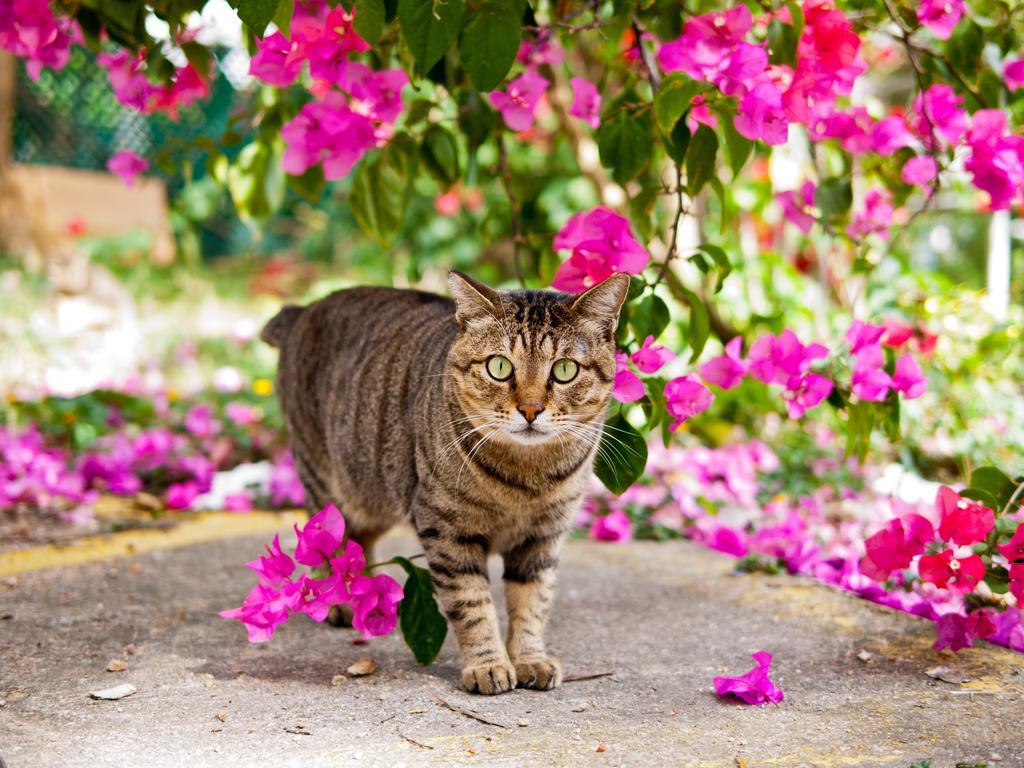Could you give a brief overview of what you see in this image? In the picture we can see a cat standing on the path and behind her we can see plants with pink color flowers and some flowers fell on the path. 